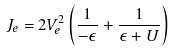Convert formula to latex. <formula><loc_0><loc_0><loc_500><loc_500>J _ { e } = 2 V _ { e } ^ { 2 } \left ( \frac { 1 } { - { \epsilon } } + \frac { 1 } { { \epsilon } + U } \right )</formula> 